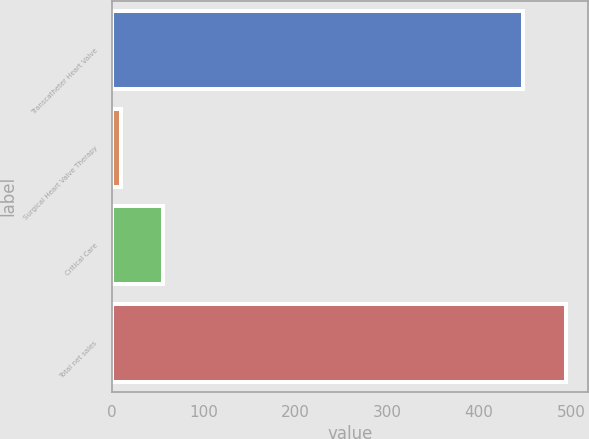Convert chart to OTSL. <chart><loc_0><loc_0><loc_500><loc_500><bar_chart><fcel>Transcatheter Heart Valve<fcel>Surgical Heart Valve Therapy<fcel>Critical Care<fcel>Total net sales<nl><fcel>448.2<fcel>10.1<fcel>56.09<fcel>494.19<nl></chart> 